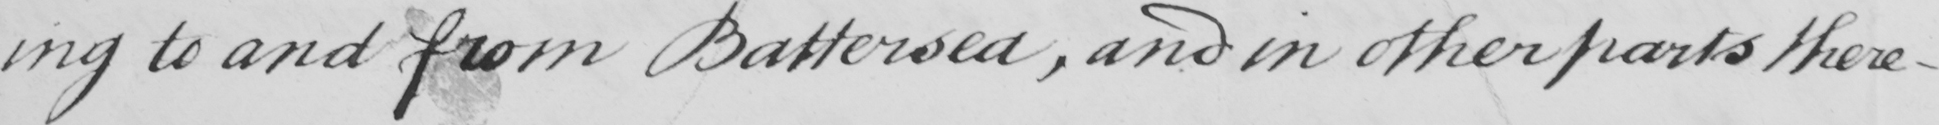What text is written in this handwritten line? -ing to and from Battersea , and in other parts there- 